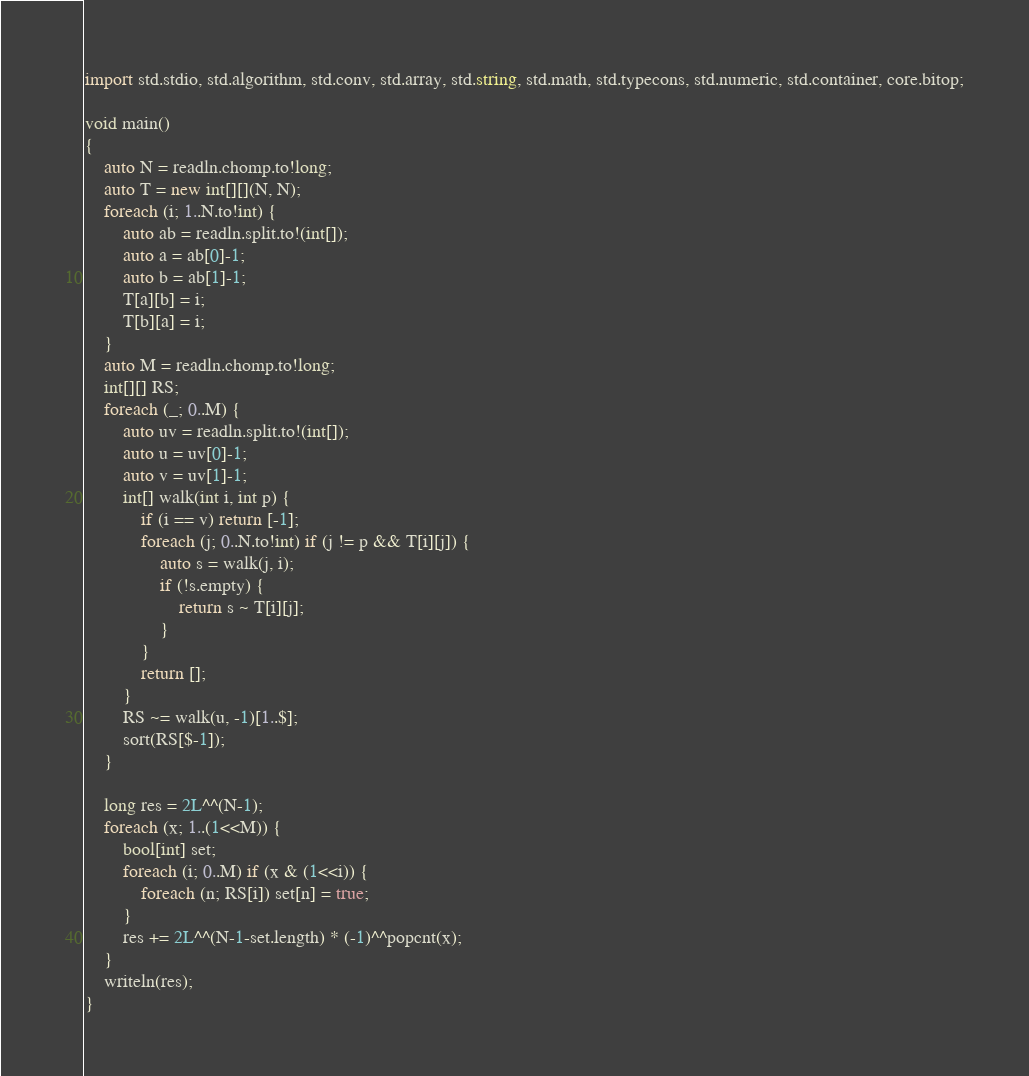<code> <loc_0><loc_0><loc_500><loc_500><_D_>import std.stdio, std.algorithm, std.conv, std.array, std.string, std.math, std.typecons, std.numeric, std.container, core.bitop;

void main()
{
    auto N = readln.chomp.to!long;
    auto T = new int[][](N, N);
    foreach (i; 1..N.to!int) {
        auto ab = readln.split.to!(int[]);
        auto a = ab[0]-1;
        auto b = ab[1]-1;
        T[a][b] = i;
        T[b][a] = i;
    }
    auto M = readln.chomp.to!long;
    int[][] RS;
    foreach (_; 0..M) {
        auto uv = readln.split.to!(int[]);
        auto u = uv[0]-1;
        auto v = uv[1]-1;
        int[] walk(int i, int p) {
            if (i == v) return [-1];
            foreach (j; 0..N.to!int) if (j != p && T[i][j]) {
                auto s = walk(j, i);
                if (!s.empty) {
                    return s ~ T[i][j];
                }
            }
            return [];
        }
        RS ~= walk(u, -1)[1..$];
        sort(RS[$-1]);
    }

    long res = 2L^^(N-1);
    foreach (x; 1..(1<<M)) {
        bool[int] set;
        foreach (i; 0..M) if (x & (1<<i)) {
            foreach (n; RS[i]) set[n] = true;
        }
        res += 2L^^(N-1-set.length) * (-1)^^popcnt(x);
    }
    writeln(res);
}</code> 